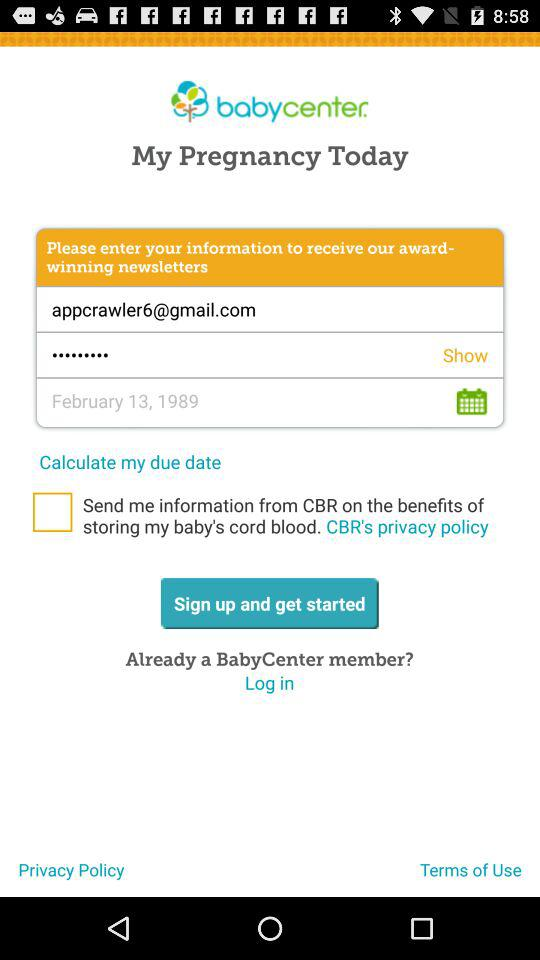What is the email address? The email address is appcrawler6@gmail.com. 